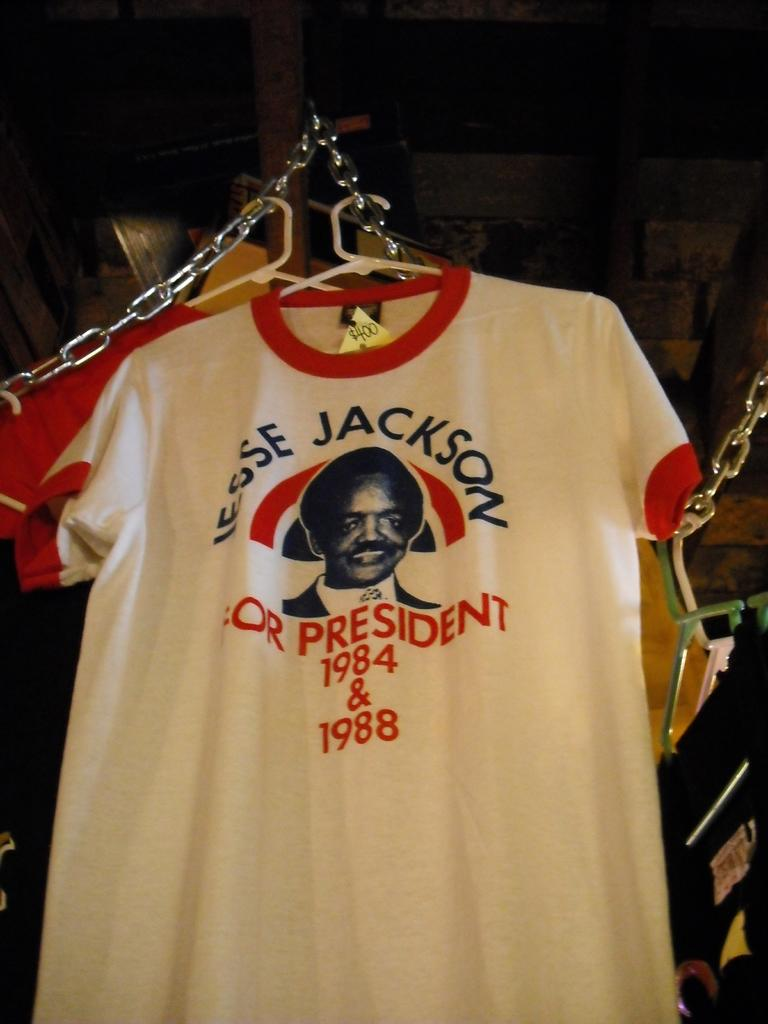<image>
Share a concise interpretation of the image provided. A T-shirt is hanging up stating JESSE JACKSON FOR PRESIDENT 1984 & 1988. 